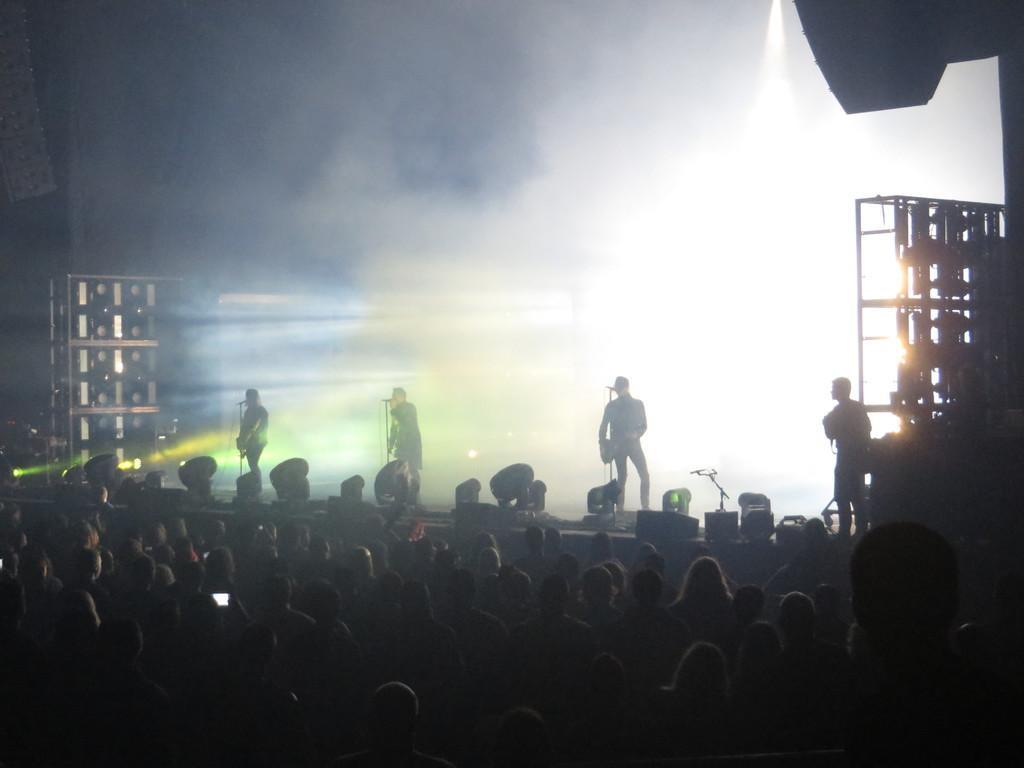Please provide a concise description of this image. In this image we can see persons holding the musical instruments and are standing on the stage in front of the mics. We can also see the focus lights and some racks on the left and on the right. At the bottom we can see many people. In the background we can see the smoke. 